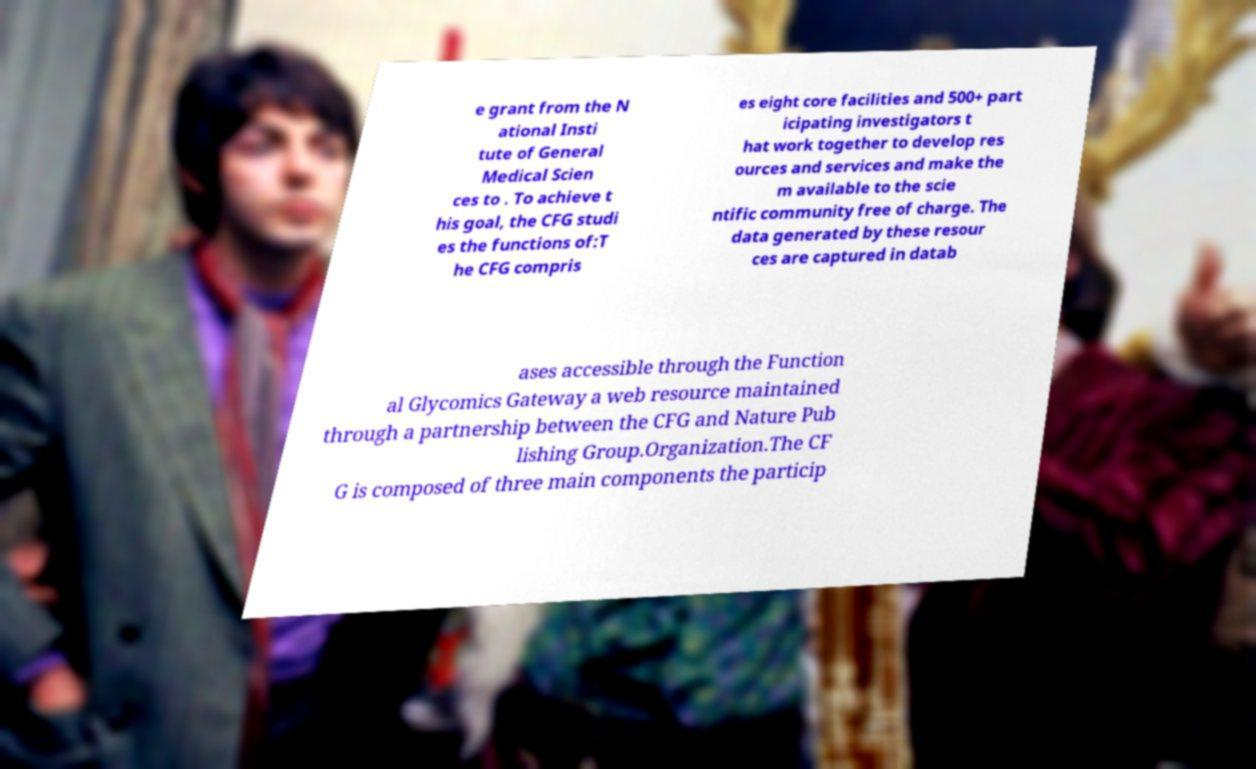There's text embedded in this image that I need extracted. Can you transcribe it verbatim? e grant from the N ational Insti tute of General Medical Scien ces to . To achieve t his goal, the CFG studi es the functions of:T he CFG compris es eight core facilities and 500+ part icipating investigators t hat work together to develop res ources and services and make the m available to the scie ntific community free of charge. The data generated by these resour ces are captured in datab ases accessible through the Function al Glycomics Gateway a web resource maintained through a partnership between the CFG and Nature Pub lishing Group.Organization.The CF G is composed of three main components the particip 